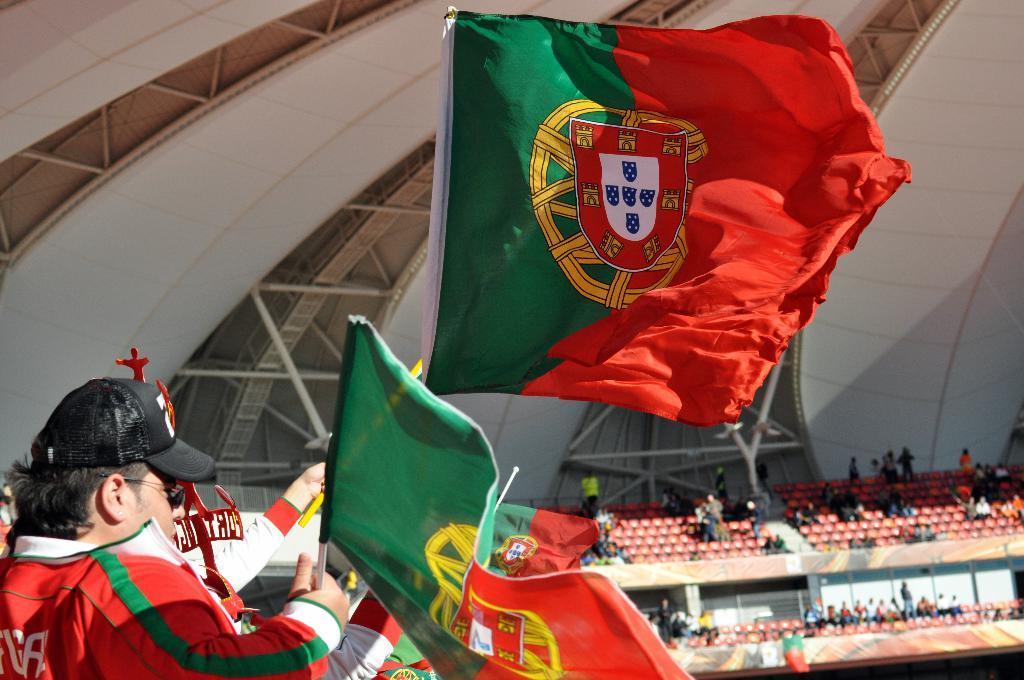Describe this image in one or two sentences. In this image we can see people sitting on the chairs in the stadium and some of them are holding flags in their hands. In the background there are iron grills. 